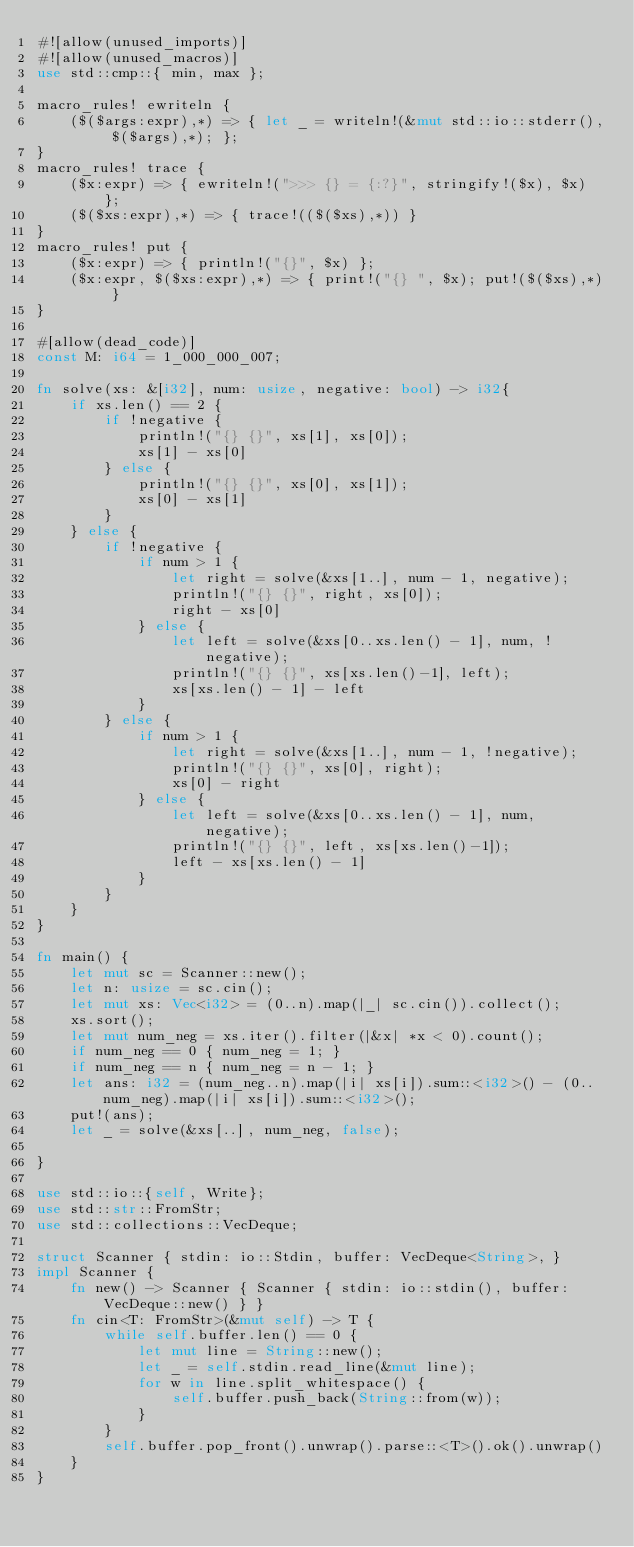<code> <loc_0><loc_0><loc_500><loc_500><_Rust_>#![allow(unused_imports)]
#![allow(unused_macros)]
use std::cmp::{ min, max };

macro_rules! ewriteln {
    ($($args:expr),*) => { let _ = writeln!(&mut std::io::stderr(), $($args),*); };
}
macro_rules! trace {
    ($x:expr) => { ewriteln!(">>> {} = {:?}", stringify!($x), $x) };
    ($($xs:expr),*) => { trace!(($($xs),*)) }
}
macro_rules! put {
    ($x:expr) => { println!("{}", $x) };
    ($x:expr, $($xs:expr),*) => { print!("{} ", $x); put!($($xs),*) }
}

#[allow(dead_code)]
const M: i64 = 1_000_000_007;

fn solve(xs: &[i32], num: usize, negative: bool) -> i32{
    if xs.len() == 2 {
        if !negative {
            println!("{} {}", xs[1], xs[0]);
            xs[1] - xs[0]
        } else {
            println!("{} {}", xs[0], xs[1]);
            xs[0] - xs[1]
        }
    } else {
        if !negative {
            if num > 1 {
                let right = solve(&xs[1..], num - 1, negative);
                println!("{} {}", right, xs[0]);
                right - xs[0]
            } else {
                let left = solve(&xs[0..xs.len() - 1], num, !negative);
                println!("{} {}", xs[xs.len()-1], left);
                xs[xs.len() - 1] - left
            }
        } else {
            if num > 1 {
                let right = solve(&xs[1..], num - 1, !negative);
                println!("{} {}", xs[0], right);
                xs[0] - right
            } else {
                let left = solve(&xs[0..xs.len() - 1], num, negative);
                println!("{} {}", left, xs[xs.len()-1]);
                left - xs[xs.len() - 1]
            }
        }
    }
}

fn main() {
    let mut sc = Scanner::new();
    let n: usize = sc.cin();
    let mut xs: Vec<i32> = (0..n).map(|_| sc.cin()).collect();
    xs.sort();
    let mut num_neg = xs.iter().filter(|&x| *x < 0).count();
    if num_neg == 0 { num_neg = 1; }
    if num_neg == n { num_neg = n - 1; }
    let ans: i32 = (num_neg..n).map(|i| xs[i]).sum::<i32>() - (0..num_neg).map(|i| xs[i]).sum::<i32>();
    put!(ans);
    let _ = solve(&xs[..], num_neg, false);

}

use std::io::{self, Write};
use std::str::FromStr;
use std::collections::VecDeque;

struct Scanner { stdin: io::Stdin, buffer: VecDeque<String>, }
impl Scanner {
    fn new() -> Scanner { Scanner { stdin: io::stdin(), buffer: VecDeque::new() } }
    fn cin<T: FromStr>(&mut self) -> T {
        while self.buffer.len() == 0 {
            let mut line = String::new();
            let _ = self.stdin.read_line(&mut line);
            for w in line.split_whitespace() {
                self.buffer.push_back(String::from(w));
            }
        }
        self.buffer.pop_front().unwrap().parse::<T>().ok().unwrap()
    }
}
</code> 